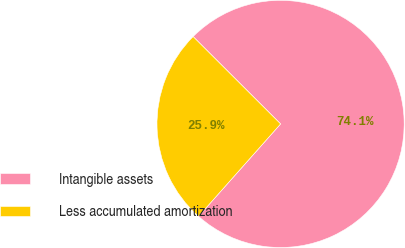<chart> <loc_0><loc_0><loc_500><loc_500><pie_chart><fcel>Intangible assets<fcel>Less accumulated amortization<nl><fcel>74.07%<fcel>25.93%<nl></chart> 